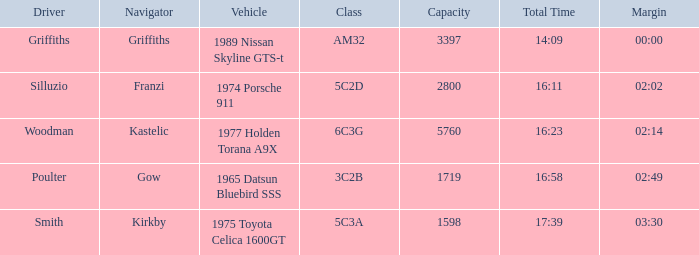Would you be able to parse every entry in this table? {'header': ['Driver', 'Navigator', 'Vehicle', 'Class', 'Capacity', 'Total Time', 'Margin'], 'rows': [['Griffiths', 'Griffiths', '1989 Nissan Skyline GTS-t', 'AM32', '3397', '14:09', '00:00'], ['Silluzio', 'Franzi', '1974 Porsche 911', '5C2D', '2800', '16:11', '02:02'], ['Woodman', 'Kastelic', '1977 Holden Torana A9X', '6C3G', '5760', '16:23', '02:14'], ['Poulter', 'Gow', '1965 Datsun Bluebird SSS', '3C2B', '1719', '16:58', '02:49'], ['Smith', 'Kirkby', '1975 Toyota Celica 1600GT', '5C3A', '1598', '17:39', '03:30']]} What driver had a total time of 16:58? Poulter. 